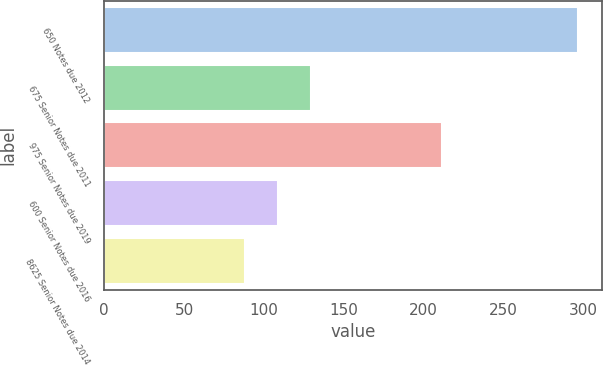Convert chart. <chart><loc_0><loc_0><loc_500><loc_500><bar_chart><fcel>650 Notes due 2012<fcel>675 Senior Notes due 2011<fcel>975 Senior Notes due 2019<fcel>600 Senior Notes due 2016<fcel>8625 Senior Notes due 2014<nl><fcel>297<fcel>129.8<fcel>212<fcel>108.9<fcel>88<nl></chart> 